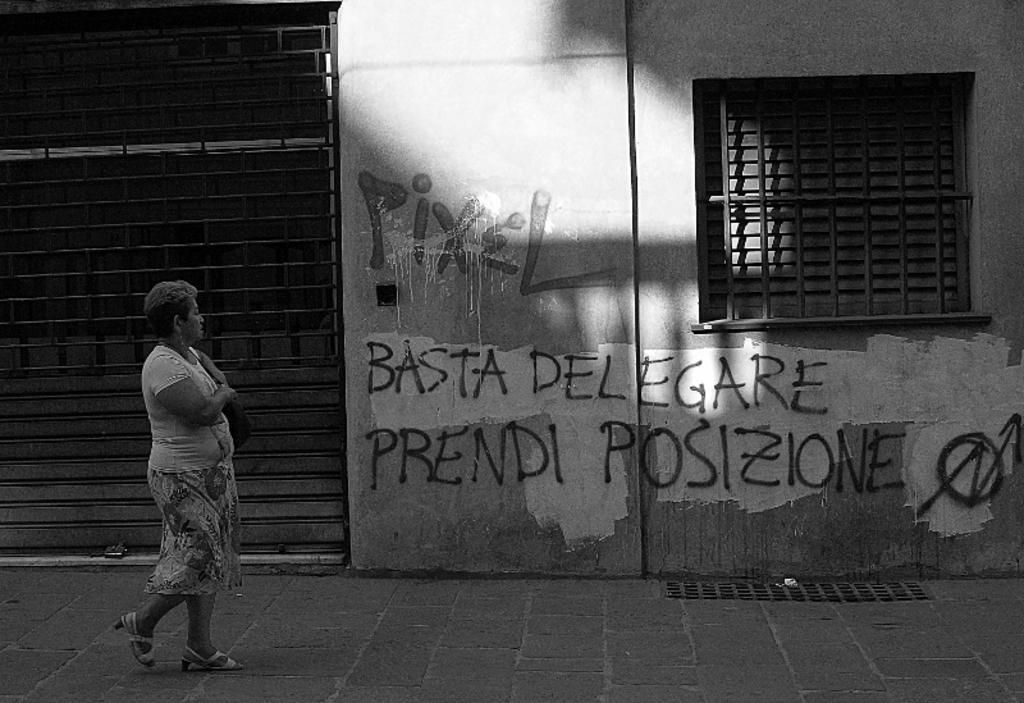Could you give a brief overview of what you see in this image? In this image I see a woman over here and I see the path. In the background I see the wall on which there is something written and I see the iron rods over here and I see that this image is of black and white in color. 